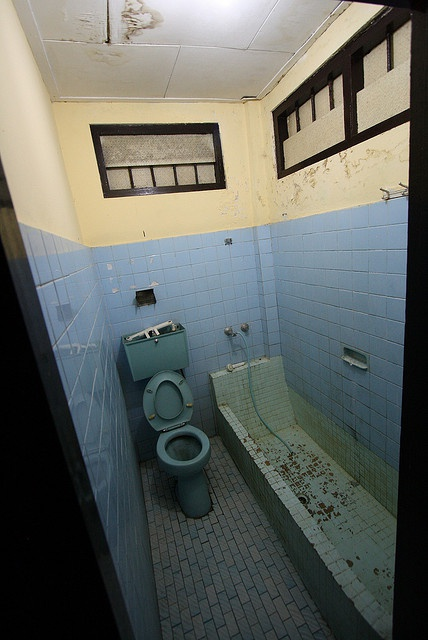Describe the objects in this image and their specific colors. I can see a toilet in lightgray, black, teal, and gray tones in this image. 